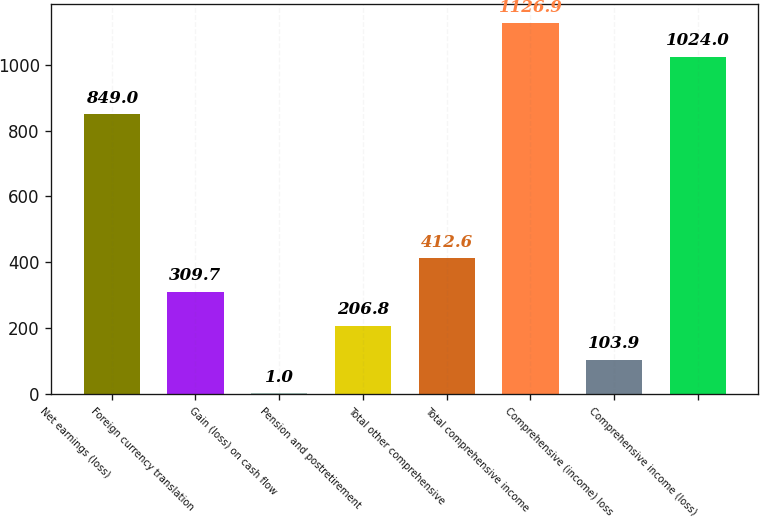Convert chart. <chart><loc_0><loc_0><loc_500><loc_500><bar_chart><fcel>Net earnings (loss)<fcel>Foreign currency translation<fcel>Gain (loss) on cash flow<fcel>Pension and postretirement<fcel>Total other comprehensive<fcel>Total comprehensive income<fcel>Comprehensive (income) loss<fcel>Comprehensive income (loss)<nl><fcel>849<fcel>309.7<fcel>1<fcel>206.8<fcel>412.6<fcel>1126.9<fcel>103.9<fcel>1024<nl></chart> 